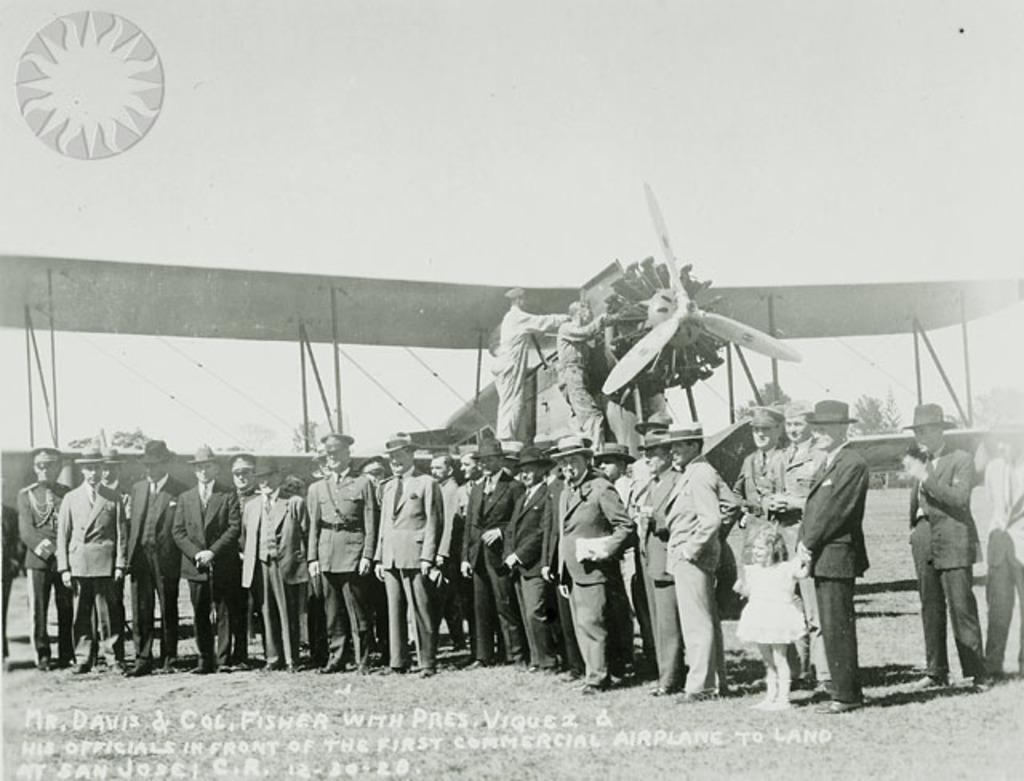<image>
Render a clear and concise summary of the photo. Mr. Davis is one of the many people standing beside the biplane. 